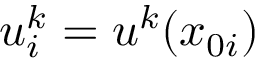Convert formula to latex. <formula><loc_0><loc_0><loc_500><loc_500>u _ { i } ^ { k } = u ^ { k } ( x _ { 0 i } )</formula> 